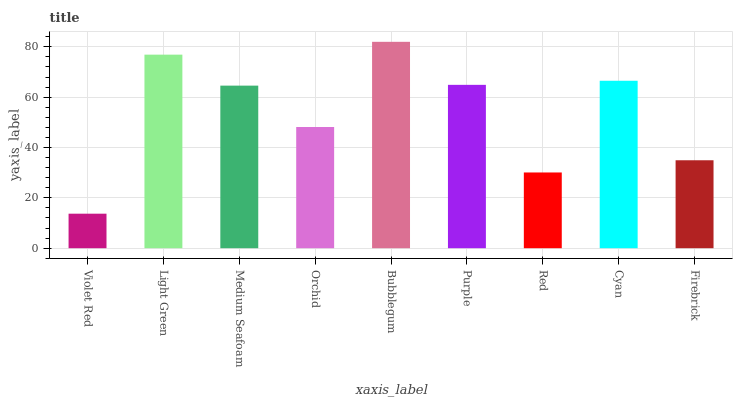Is Violet Red the minimum?
Answer yes or no. Yes. Is Bubblegum the maximum?
Answer yes or no. Yes. Is Light Green the minimum?
Answer yes or no. No. Is Light Green the maximum?
Answer yes or no. No. Is Light Green greater than Violet Red?
Answer yes or no. Yes. Is Violet Red less than Light Green?
Answer yes or no. Yes. Is Violet Red greater than Light Green?
Answer yes or no. No. Is Light Green less than Violet Red?
Answer yes or no. No. Is Medium Seafoam the high median?
Answer yes or no. Yes. Is Medium Seafoam the low median?
Answer yes or no. Yes. Is Orchid the high median?
Answer yes or no. No. Is Firebrick the low median?
Answer yes or no. No. 